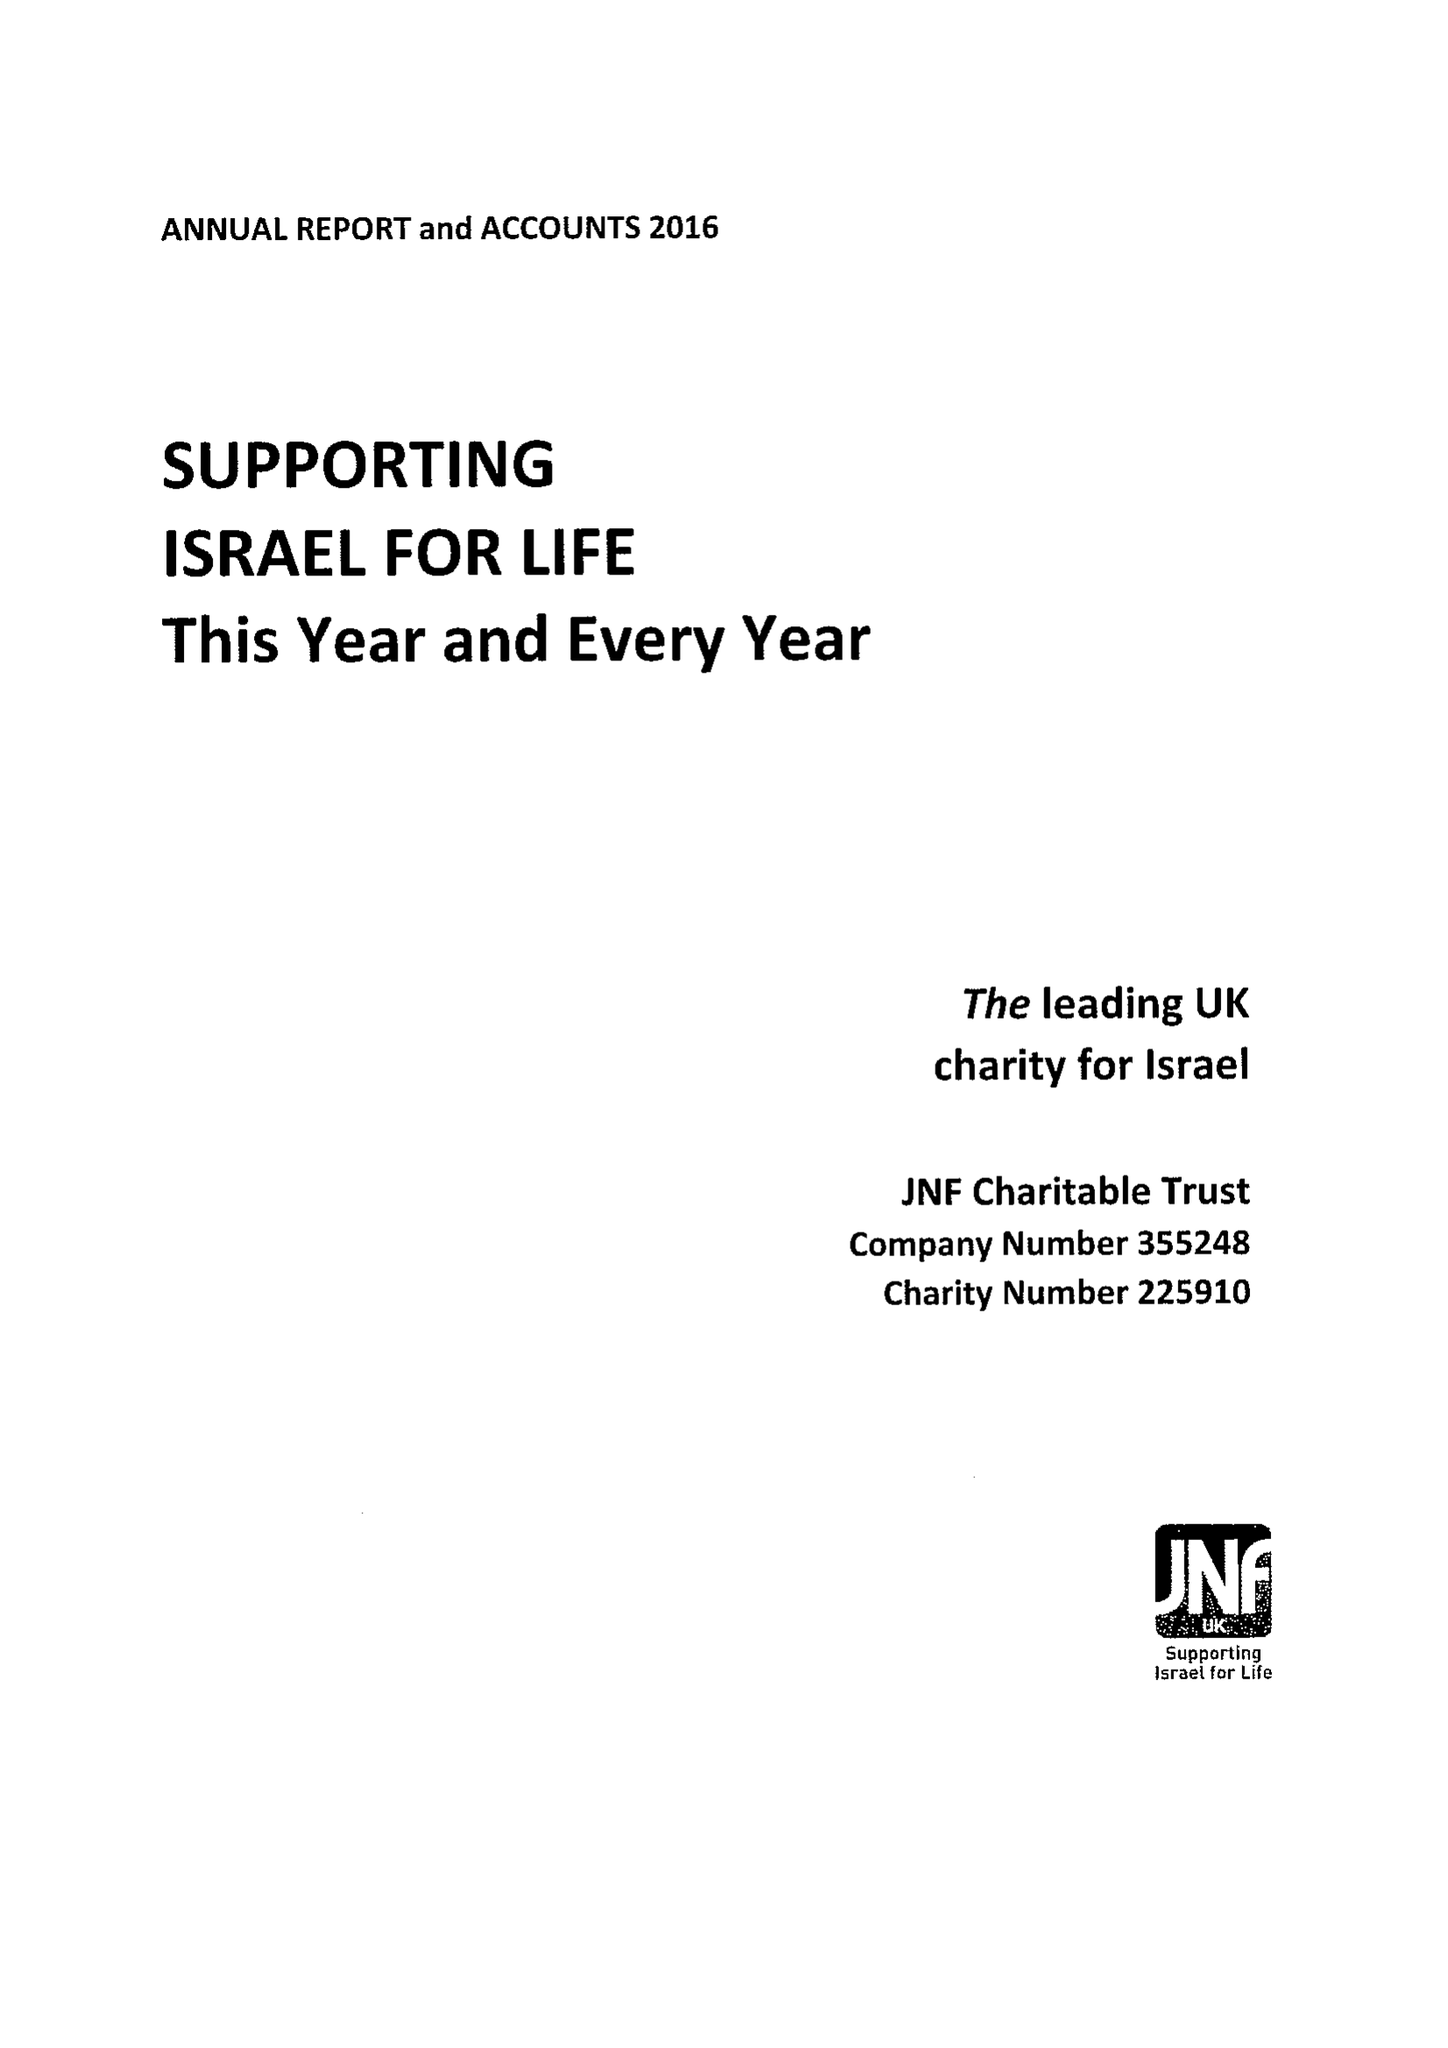What is the value for the charity_number?
Answer the question using a single word or phrase. 225910 